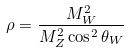<formula> <loc_0><loc_0><loc_500><loc_500>\rho = \frac { M _ { W } ^ { 2 } } { M _ { Z } ^ { 2 } \cos ^ { 2 } \theta _ { W } }</formula> 